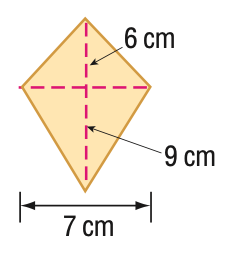Question: Find the area of the kite.
Choices:
A. 42
B. 52.5
C. 54
D. 63
Answer with the letter. Answer: B 